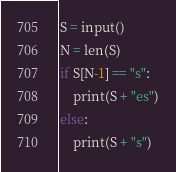Convert code to text. <code><loc_0><loc_0><loc_500><loc_500><_Python_>S = input()
N = len(S)
if S[N-1] == "s":
    print(S + "es")
else:
    print(S + "s")</code> 